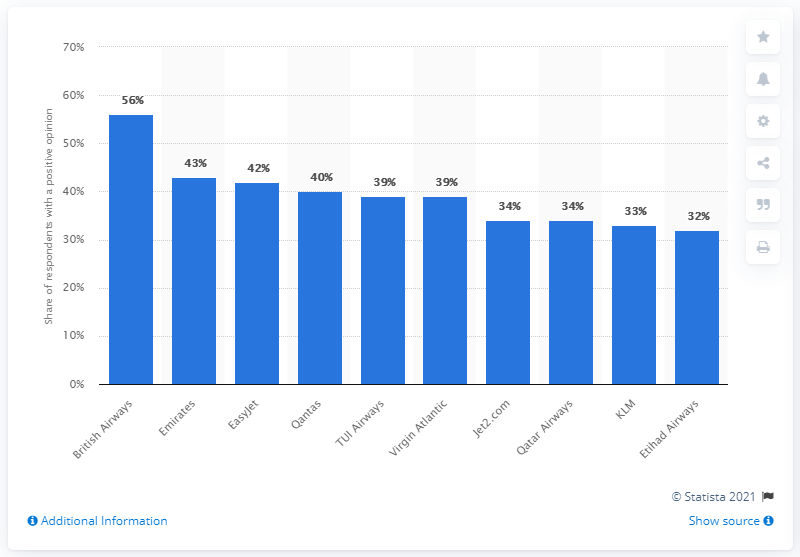Identify some key points in this picture. British Airways is the most popular airline in the UK. 